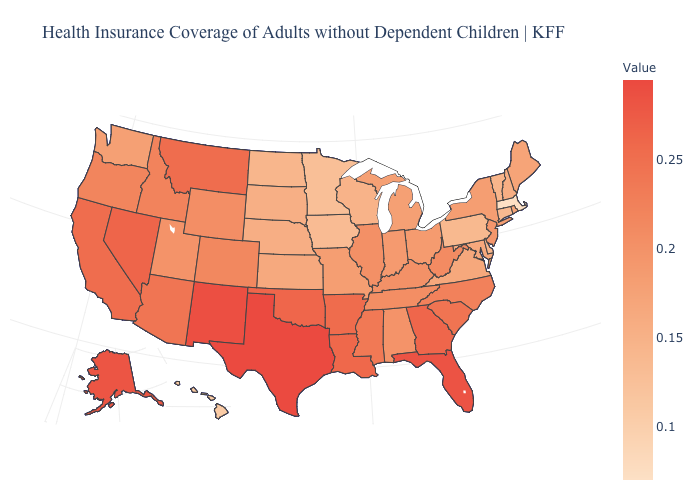Which states have the lowest value in the USA?
Concise answer only. Massachusetts. Does Massachusetts have the highest value in the USA?
Keep it brief. No. Does New Mexico have the highest value in the West?
Concise answer only. Yes. Is the legend a continuous bar?
Give a very brief answer. Yes. Does Colorado have a higher value than New Hampshire?
Be succinct. Yes. Which states have the highest value in the USA?
Be succinct. Texas. Among the states that border Washington , which have the highest value?
Answer briefly. Idaho. 